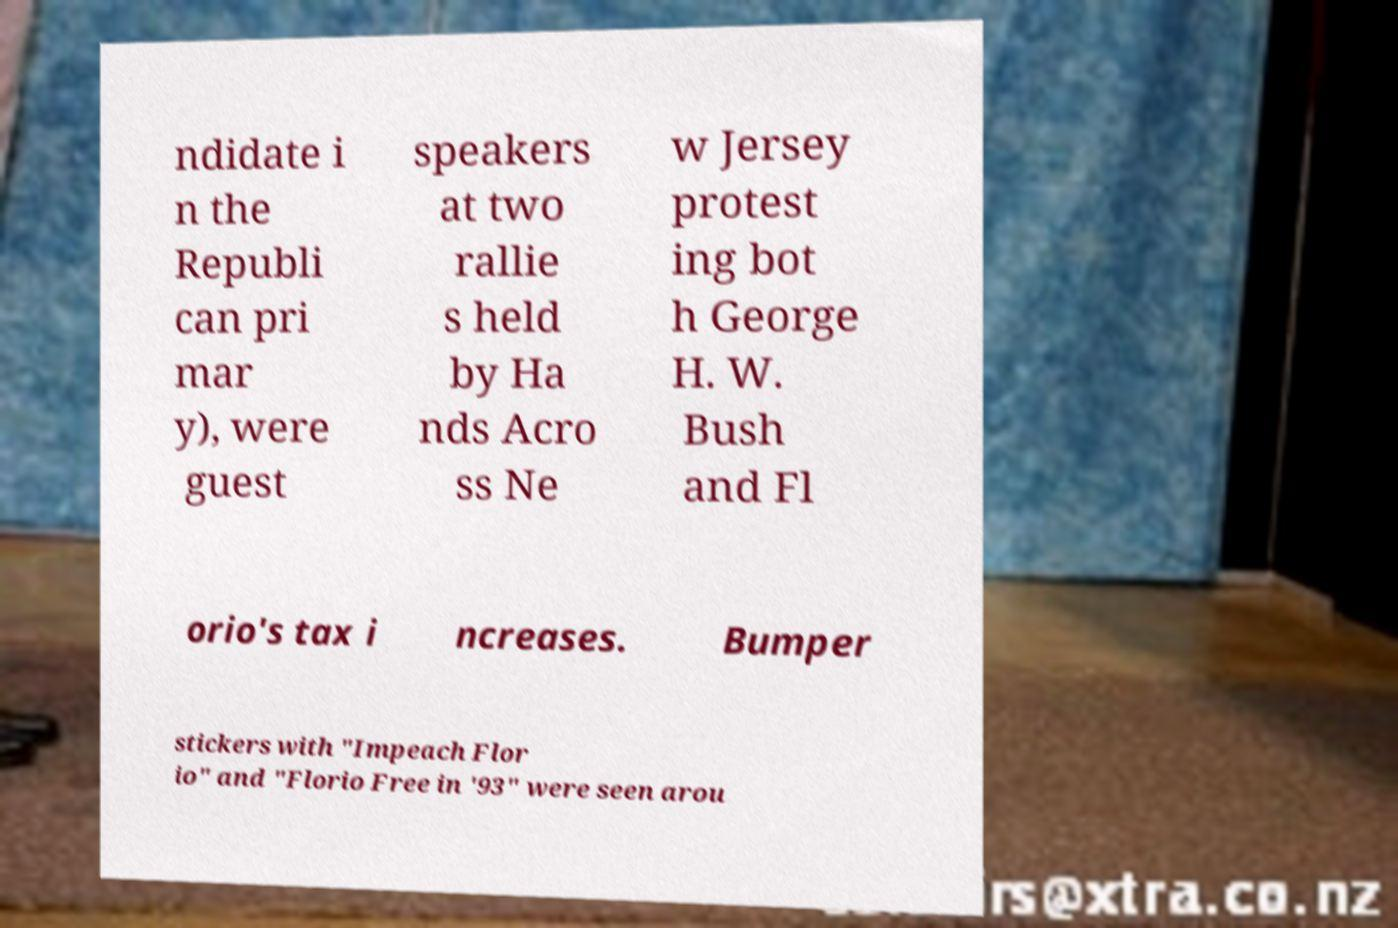I need the written content from this picture converted into text. Can you do that? ndidate i n the Republi can pri mar y), were guest speakers at two rallie s held by Ha nds Acro ss Ne w Jersey protest ing bot h George H. W. Bush and Fl orio's tax i ncreases. Bumper stickers with "Impeach Flor io" and "Florio Free in '93" were seen arou 